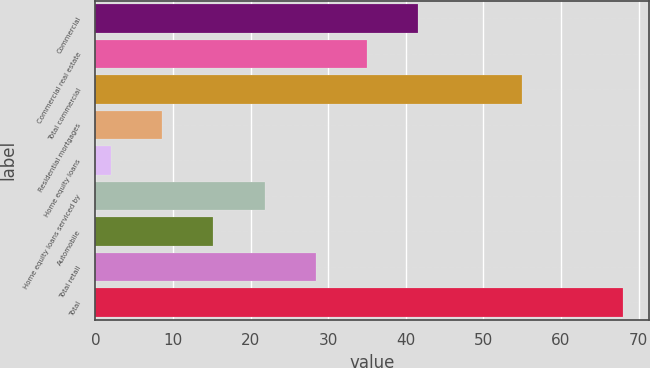<chart> <loc_0><loc_0><loc_500><loc_500><bar_chart><fcel>Commercial<fcel>Commercial real estate<fcel>Total commercial<fcel>Residential mortgages<fcel>Home equity loans<fcel>Home equity loans serviced by<fcel>Automobile<fcel>Total retail<fcel>Total<nl><fcel>41.6<fcel>35<fcel>55<fcel>8.6<fcel>2<fcel>21.8<fcel>15.2<fcel>28.4<fcel>68<nl></chart> 